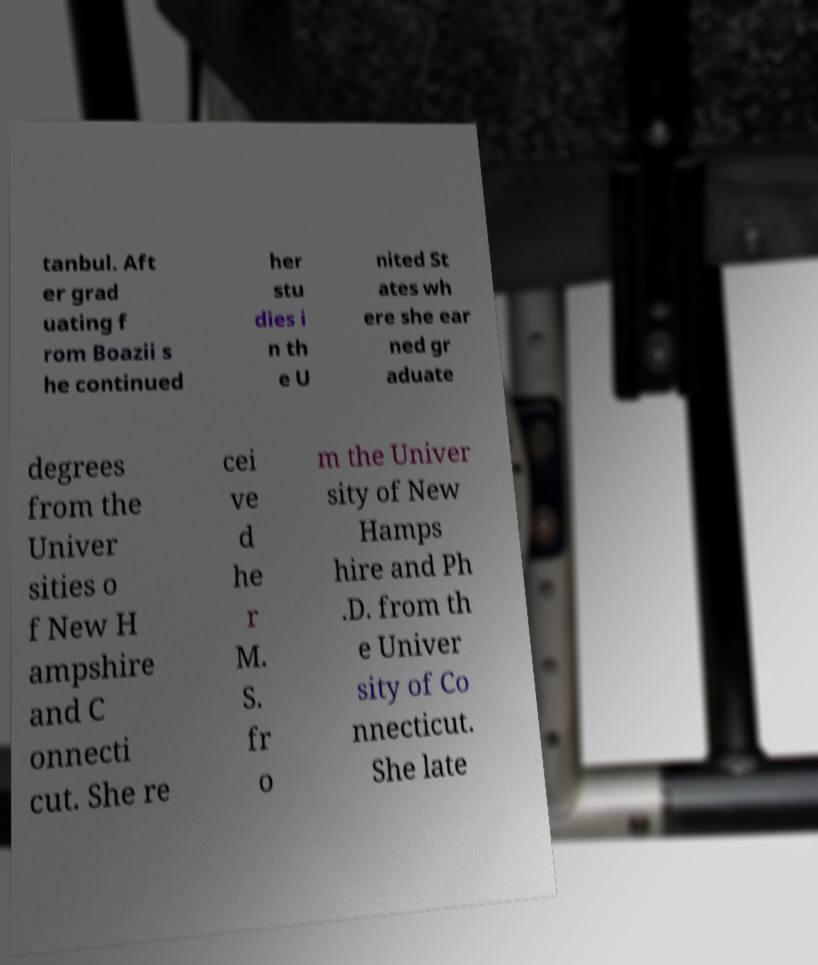There's text embedded in this image that I need extracted. Can you transcribe it verbatim? tanbul. Aft er grad uating f rom Boazii s he continued her stu dies i n th e U nited St ates wh ere she ear ned gr aduate degrees from the Univer sities o f New H ampshire and C onnecti cut. She re cei ve d he r M. S. fr o m the Univer sity of New Hamps hire and Ph .D. from th e Univer sity of Co nnecticut. She late 